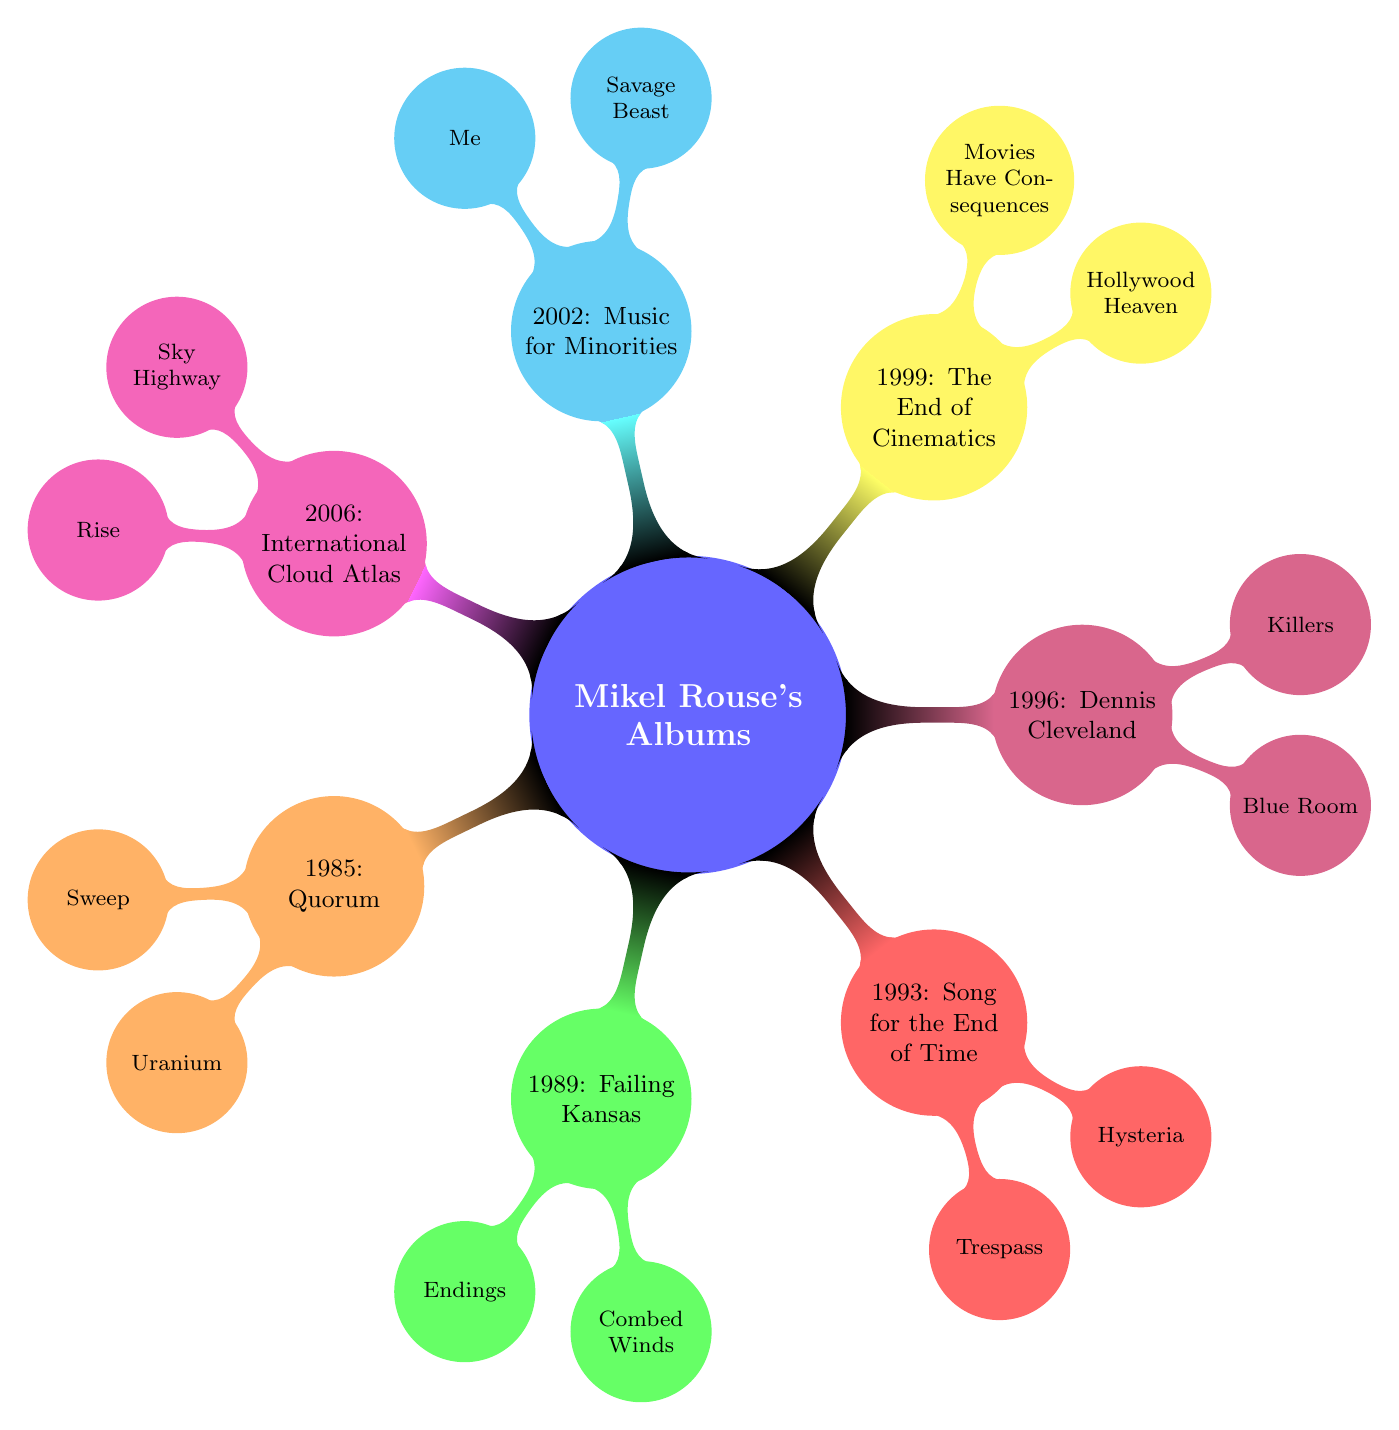What's the first album released by Mikel Rouse? According to the diagram, the first album listed is "Quorum," which was released in 1985.
Answer: Quorum How many key tracks are in the album "Failing Kansas"? The diagram shows that "Failing Kansas," released in 1989, has two key tracks: "Endings" and "Combed Winds." Thus, the total number of key tracks is 2.
Answer: 2 Which album features the track "Sky Highway"? The diagram indicates that "Sky Highway" is a key track from the album "International Cloud Atlas," which was released in 2006.
Answer: International Cloud Atlas In which year was "Music for Minorities" released? By examining the diagram, "Music for Minorities" is shown to have been released in 2002.
Answer: 2002 What are the key tracks of "The End of Cinematics"? The key tracks listed for "The End of Cinematics," released in 1999, are "Hollywood Heaven" and "Movies Have Consequences."
Answer: Hollywood Heaven, Movies Have Consequences Which album was released immediately after "Song for the End of Time"? The diagram indicates that "Song for the End of Time" was released in 1993, and the subsequent album, "Dennis Cleveland," was released in 1996. Hence, "Dennis Cleveland" is the answer.
Answer: Dennis Cleveland Count the total number of albums shown in the diagram. The diagram lists seven albums: "Quorum," "Failing Kansas," "Song for the End of Time," "Dennis Cleveland," "The End of Cinematics," "Music for Minorities," and "International Cloud Atlas." Therefore, the total is 7.
Answer: 7 Which key track is associated with the album "Dennis Cleveland"? The diagram indicates that the key tracks associated with "Dennis Cleveland," released in 1996, are "Blue Room" and "Killers." Therefore, any of these tracks is an acceptable answer.
Answer: Blue Room (or Killers) 